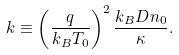Convert formula to latex. <formula><loc_0><loc_0><loc_500><loc_500>k \equiv \left ( \frac { q } { k _ { B } T _ { 0 } } \right ) ^ { 2 } \frac { k _ { B } D n _ { 0 } } { \kappa } .</formula> 